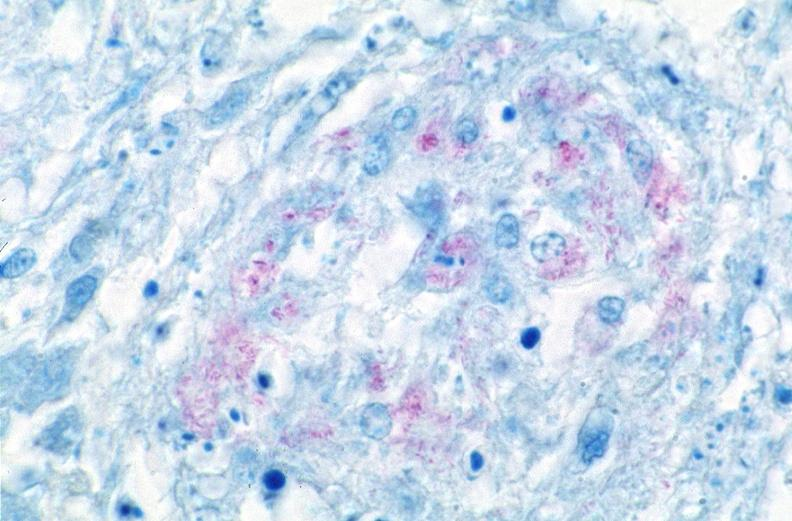does hemochromatosis show lung, mycobacterium tuberculosis, acid fast?
Answer the question using a single word or phrase. No 